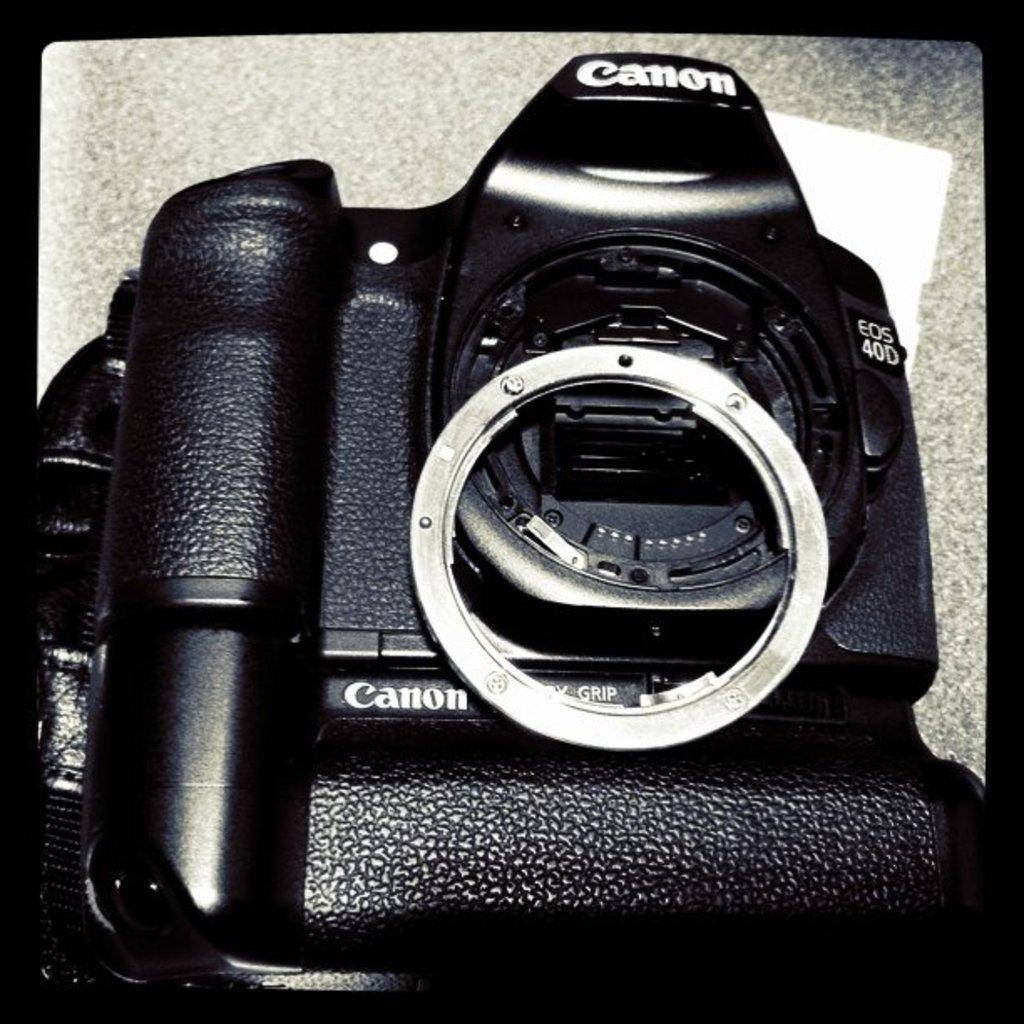What object is the main subject of the image? There is a camera in the image. What type of worm is crawling on the camera in the image? There is no worm present in the image; it only features a camera. 